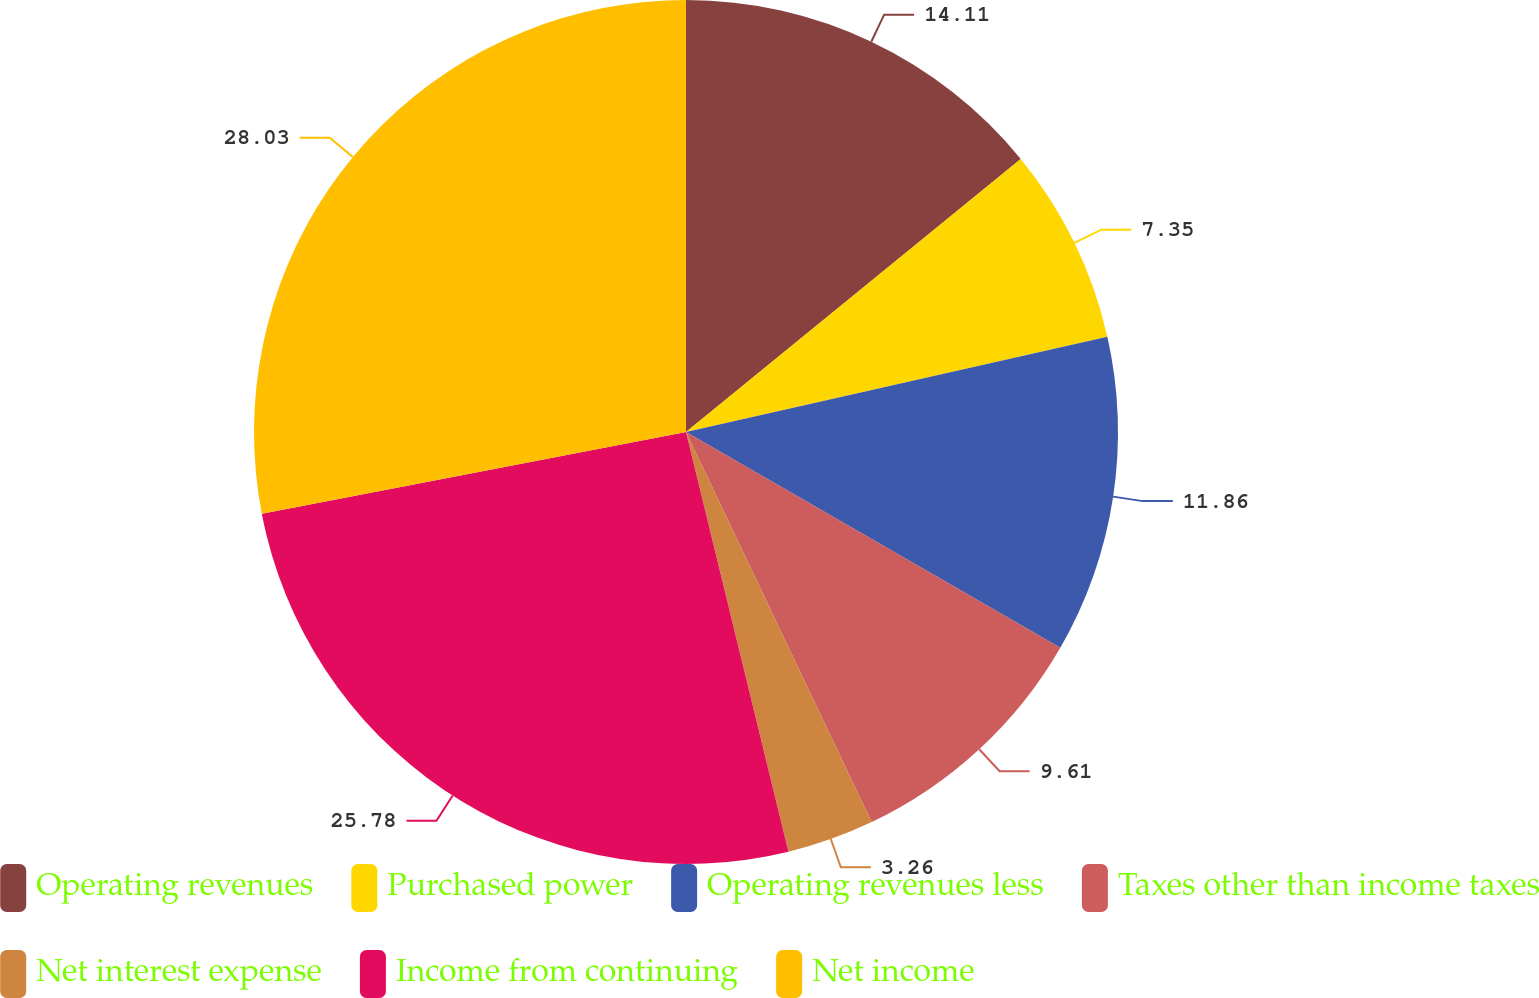<chart> <loc_0><loc_0><loc_500><loc_500><pie_chart><fcel>Operating revenues<fcel>Purchased power<fcel>Operating revenues less<fcel>Taxes other than income taxes<fcel>Net interest expense<fcel>Income from continuing<fcel>Net income<nl><fcel>14.11%<fcel>7.35%<fcel>11.86%<fcel>9.61%<fcel>3.26%<fcel>25.78%<fcel>28.03%<nl></chart> 